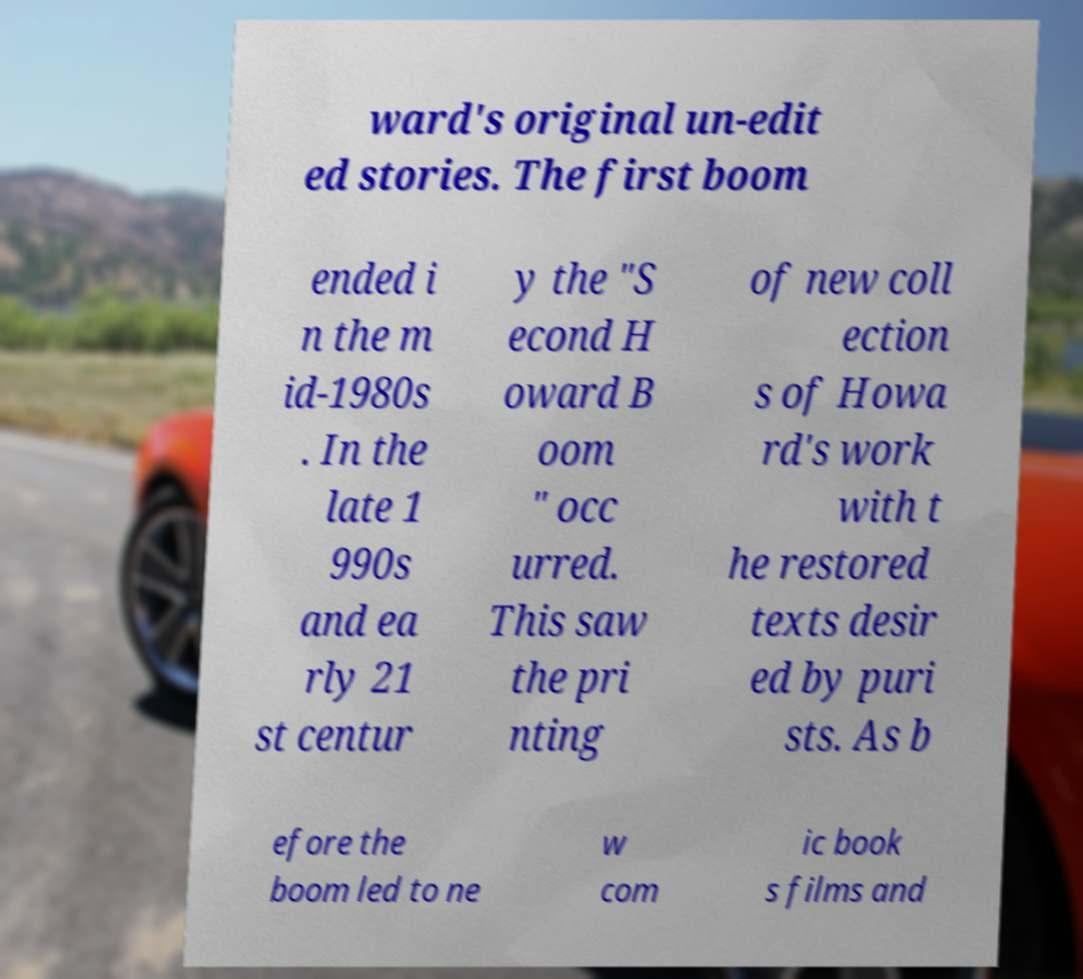For documentation purposes, I need the text within this image transcribed. Could you provide that? ward's original un-edit ed stories. The first boom ended i n the m id-1980s . In the late 1 990s and ea rly 21 st centur y the "S econd H oward B oom " occ urred. This saw the pri nting of new coll ection s of Howa rd's work with t he restored texts desir ed by puri sts. As b efore the boom led to ne w com ic book s films and 